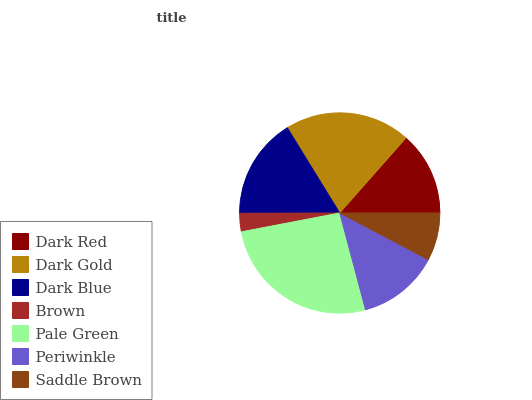Is Brown the minimum?
Answer yes or no. Yes. Is Pale Green the maximum?
Answer yes or no. Yes. Is Dark Gold the minimum?
Answer yes or no. No. Is Dark Gold the maximum?
Answer yes or no. No. Is Dark Gold greater than Dark Red?
Answer yes or no. Yes. Is Dark Red less than Dark Gold?
Answer yes or no. Yes. Is Dark Red greater than Dark Gold?
Answer yes or no. No. Is Dark Gold less than Dark Red?
Answer yes or no. No. Is Dark Red the high median?
Answer yes or no. Yes. Is Dark Red the low median?
Answer yes or no. Yes. Is Pale Green the high median?
Answer yes or no. No. Is Brown the low median?
Answer yes or no. No. 